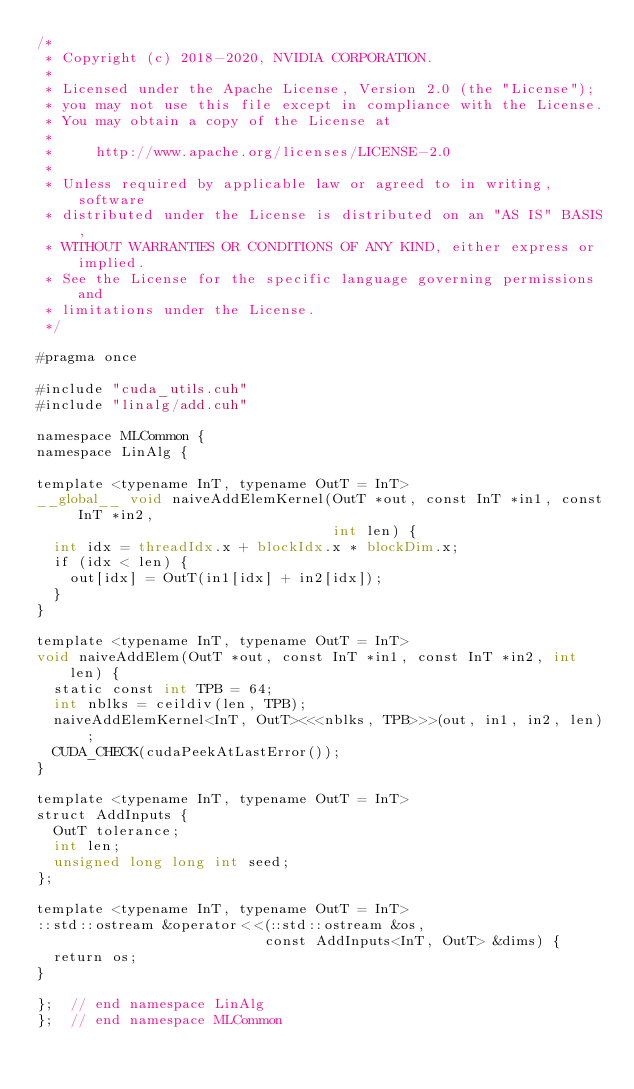<code> <loc_0><loc_0><loc_500><loc_500><_Cuda_>/*
 * Copyright (c) 2018-2020, NVIDIA CORPORATION.
 *
 * Licensed under the Apache License, Version 2.0 (the "License");
 * you may not use this file except in compliance with the License.
 * You may obtain a copy of the License at
 *
 *     http://www.apache.org/licenses/LICENSE-2.0
 *
 * Unless required by applicable law or agreed to in writing, software
 * distributed under the License is distributed on an "AS IS" BASIS,
 * WITHOUT WARRANTIES OR CONDITIONS OF ANY KIND, either express or implied.
 * See the License for the specific language governing permissions and
 * limitations under the License.
 */

#pragma once

#include "cuda_utils.cuh"
#include "linalg/add.cuh"

namespace MLCommon {
namespace LinAlg {

template <typename InT, typename OutT = InT>
__global__ void naiveAddElemKernel(OutT *out, const InT *in1, const InT *in2,
                                   int len) {
  int idx = threadIdx.x + blockIdx.x * blockDim.x;
  if (idx < len) {
    out[idx] = OutT(in1[idx] + in2[idx]);
  }
}

template <typename InT, typename OutT = InT>
void naiveAddElem(OutT *out, const InT *in1, const InT *in2, int len) {
  static const int TPB = 64;
  int nblks = ceildiv(len, TPB);
  naiveAddElemKernel<InT, OutT><<<nblks, TPB>>>(out, in1, in2, len);
  CUDA_CHECK(cudaPeekAtLastError());
}

template <typename InT, typename OutT = InT>
struct AddInputs {
  OutT tolerance;
  int len;
  unsigned long long int seed;
};

template <typename InT, typename OutT = InT>
::std::ostream &operator<<(::std::ostream &os,
                           const AddInputs<InT, OutT> &dims) {
  return os;
}

};  // end namespace LinAlg
};  // end namespace MLCommon
</code> 